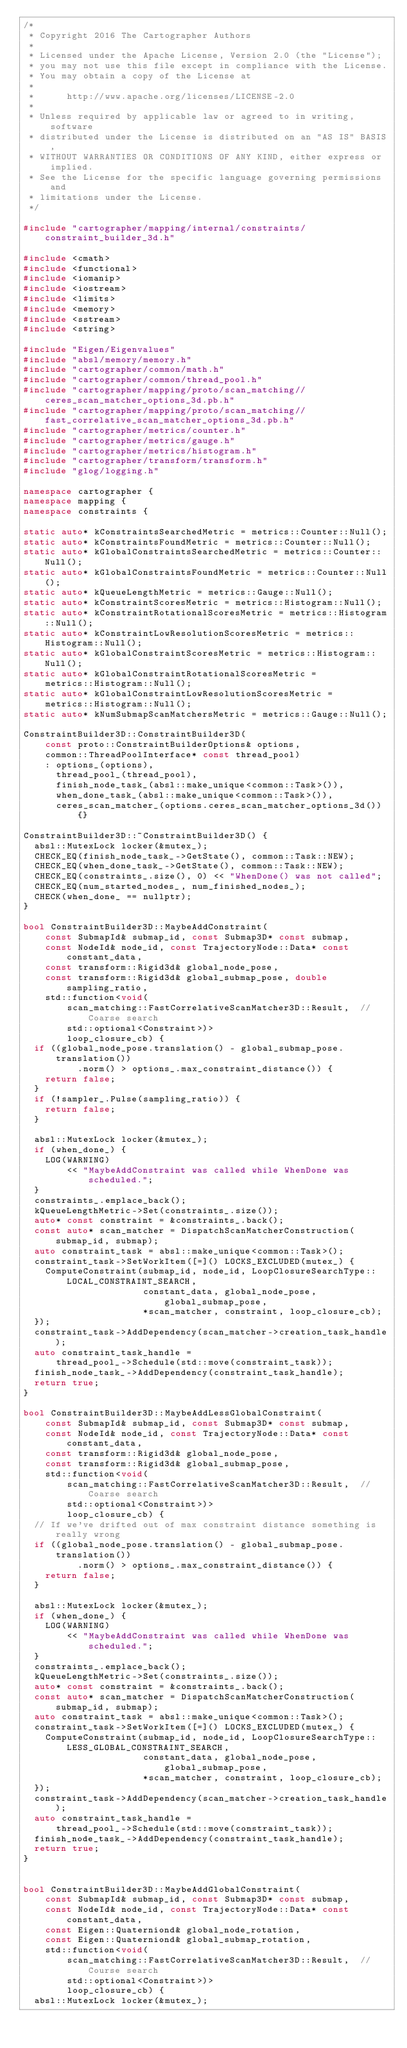<code> <loc_0><loc_0><loc_500><loc_500><_C++_>/*
 * Copyright 2016 The Cartographer Authors
 *
 * Licensed under the Apache License, Version 2.0 (the "License");
 * you may not use this file except in compliance with the License.
 * You may obtain a copy of the License at
 *
 *      http://www.apache.org/licenses/LICENSE-2.0
 *
 * Unless required by applicable law or agreed to in writing, software
 * distributed under the License is distributed on an "AS IS" BASIS,
 * WITHOUT WARRANTIES OR CONDITIONS OF ANY KIND, either express or implied.
 * See the License for the specific language governing permissions and
 * limitations under the License.
 */

#include "cartographer/mapping/internal/constraints/constraint_builder_3d.h"

#include <cmath>
#include <functional>
#include <iomanip>
#include <iostream>
#include <limits>
#include <memory>
#include <sstream>
#include <string>

#include "Eigen/Eigenvalues"
#include "absl/memory/memory.h"
#include "cartographer/common/math.h"
#include "cartographer/common/thread_pool.h"
#include "cartographer/mapping/proto/scan_matching//ceres_scan_matcher_options_3d.pb.h"
#include "cartographer/mapping/proto/scan_matching//fast_correlative_scan_matcher_options_3d.pb.h"
#include "cartographer/metrics/counter.h"
#include "cartographer/metrics/gauge.h"
#include "cartographer/metrics/histogram.h"
#include "cartographer/transform/transform.h"
#include "glog/logging.h"

namespace cartographer {
namespace mapping {
namespace constraints {

static auto* kConstraintsSearchedMetric = metrics::Counter::Null();
static auto* kConstraintsFoundMetric = metrics::Counter::Null();
static auto* kGlobalConstraintsSearchedMetric = metrics::Counter::Null();
static auto* kGlobalConstraintsFoundMetric = metrics::Counter::Null();
static auto* kQueueLengthMetric = metrics::Gauge::Null();
static auto* kConstraintScoresMetric = metrics::Histogram::Null();
static auto* kConstraintRotationalScoresMetric = metrics::Histogram::Null();
static auto* kConstraintLowResolutionScoresMetric = metrics::Histogram::Null();
static auto* kGlobalConstraintScoresMetric = metrics::Histogram::Null();
static auto* kGlobalConstraintRotationalScoresMetric =
    metrics::Histogram::Null();
static auto* kGlobalConstraintLowResolutionScoresMetric =
    metrics::Histogram::Null();
static auto* kNumSubmapScanMatchersMetric = metrics::Gauge::Null();

ConstraintBuilder3D::ConstraintBuilder3D(
    const proto::ConstraintBuilderOptions& options,
    common::ThreadPoolInterface* const thread_pool)
    : options_(options),
      thread_pool_(thread_pool),
      finish_node_task_(absl::make_unique<common::Task>()),
      when_done_task_(absl::make_unique<common::Task>()),
      ceres_scan_matcher_(options.ceres_scan_matcher_options_3d()) {}

ConstraintBuilder3D::~ConstraintBuilder3D() {
  absl::MutexLock locker(&mutex_);
  CHECK_EQ(finish_node_task_->GetState(), common::Task::NEW);
  CHECK_EQ(when_done_task_->GetState(), common::Task::NEW);
  CHECK_EQ(constraints_.size(), 0) << "WhenDone() was not called";
  CHECK_EQ(num_started_nodes_, num_finished_nodes_);
  CHECK(when_done_ == nullptr);
}

bool ConstraintBuilder3D::MaybeAddConstraint(
    const SubmapId& submap_id, const Submap3D* const submap,
    const NodeId& node_id, const TrajectoryNode::Data* const constant_data,
    const transform::Rigid3d& global_node_pose,
    const transform::Rigid3d& global_submap_pose, double sampling_ratio,
    std::function<void(
        scan_matching::FastCorrelativeScanMatcher3D::Result,  // Coarse search
        std::optional<Constraint>)>
        loop_closure_cb) {
  if ((global_node_pose.translation() - global_submap_pose.translation())
          .norm() > options_.max_constraint_distance()) {
    return false;
  }
  if (!sampler_.Pulse(sampling_ratio)) {
    return false;
  }

  absl::MutexLock locker(&mutex_);
  if (when_done_) {
    LOG(WARNING)
        << "MaybeAddConstraint was called while WhenDone was scheduled.";
  }
  constraints_.emplace_back();
  kQueueLengthMetric->Set(constraints_.size());
  auto* const constraint = &constraints_.back();
  const auto* scan_matcher = DispatchScanMatcherConstruction(submap_id, submap);
  auto constraint_task = absl::make_unique<common::Task>();
  constraint_task->SetWorkItem([=]() LOCKS_EXCLUDED(mutex_) {
    ComputeConstraint(submap_id, node_id, LoopClosureSearchType::LOCAL_CONSTRAINT_SEARCH,
                      constant_data, global_node_pose, global_submap_pose,
                      *scan_matcher, constraint, loop_closure_cb);
  });
  constraint_task->AddDependency(scan_matcher->creation_task_handle);
  auto constraint_task_handle =
      thread_pool_->Schedule(std::move(constraint_task));
  finish_node_task_->AddDependency(constraint_task_handle);
  return true;
}

bool ConstraintBuilder3D::MaybeAddLessGlobalConstraint(
    const SubmapId& submap_id, const Submap3D* const submap,
    const NodeId& node_id, const TrajectoryNode::Data* const constant_data,
    const transform::Rigid3d& global_node_pose,
    const transform::Rigid3d& global_submap_pose,
    std::function<void(
        scan_matching::FastCorrelativeScanMatcher3D::Result,  // Coarse search
        std::optional<Constraint>)>
        loop_closure_cb) {
  // If we've drifted out of max constraint distance something is really wrong
  if ((global_node_pose.translation() - global_submap_pose.translation())
          .norm() > options_.max_constraint_distance()) {
    return false;
  }

  absl::MutexLock locker(&mutex_);
  if (when_done_) {
    LOG(WARNING)
        << "MaybeAddConstraint was called while WhenDone was scheduled.";
  }
  constraints_.emplace_back();
  kQueueLengthMetric->Set(constraints_.size());
  auto* const constraint = &constraints_.back();
  const auto* scan_matcher = DispatchScanMatcherConstruction(submap_id, submap);
  auto constraint_task = absl::make_unique<common::Task>();
  constraint_task->SetWorkItem([=]() LOCKS_EXCLUDED(mutex_) {
    ComputeConstraint(submap_id, node_id, LoopClosureSearchType::LESS_GLOBAL_CONSTRAINT_SEARCH,
                      constant_data, global_node_pose, global_submap_pose,
                      *scan_matcher, constraint, loop_closure_cb);
  });
  constraint_task->AddDependency(scan_matcher->creation_task_handle);
  auto constraint_task_handle =
      thread_pool_->Schedule(std::move(constraint_task));
  finish_node_task_->AddDependency(constraint_task_handle);
  return true;
}


bool ConstraintBuilder3D::MaybeAddGlobalConstraint(
    const SubmapId& submap_id, const Submap3D* const submap,
    const NodeId& node_id, const TrajectoryNode::Data* const constant_data,
    const Eigen::Quaterniond& global_node_rotation,
    const Eigen::Quaterniond& global_submap_rotation,
    std::function<void(
        scan_matching::FastCorrelativeScanMatcher3D::Result,  // Course search
        std::optional<Constraint>)>
        loop_closure_cb) {
  absl::MutexLock locker(&mutex_);</code> 